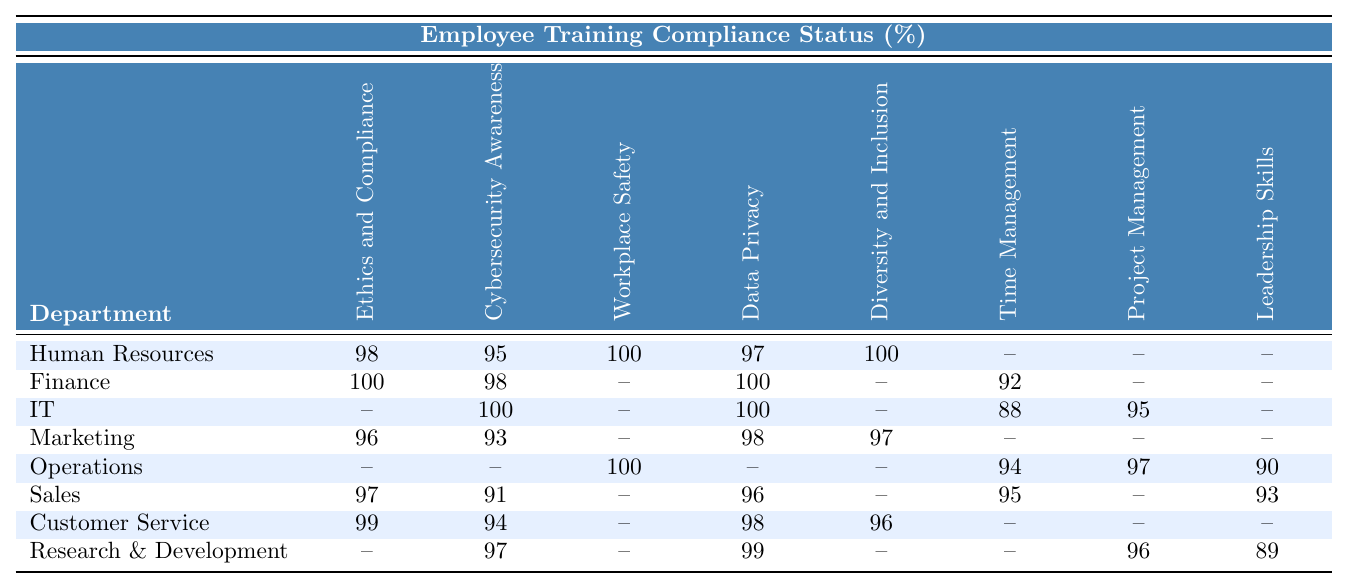What is the compliance percentage for "Diversity and Inclusion" in Human Resources? The compliance percentage for the "Diversity and Inclusion" training in the Human Resources department is explicitly listed in the table. It shows a value of 100%.
Answer: 100% Which department has the highest compliance in "Data Privacy"? The department with the highest compliance in "Data Privacy" is Finance, with a compliance rate of 100%.
Answer: Finance Are there any departments that have completed the "Workplace Safety" training? Yes, both Human Resources and Operations have completed the "Workplace Safety" training with a compliance rate of 100%.
Answer: Yes What is the average compliance percentage for "Cybersecurity Awareness" across all departments? To find the average for "Cybersecurity Awareness," we sum the values: 95 (HR) + 98 (Finance) + 100 (IT) + 93 (Marketing) + 91 (Sales) + 94 (Customer Service) + 97 (R&D) = 568. There are 7 departments that have a compliance rate recorded for this training, so we divide 568 by 7 to get approximately 81.14.
Answer: Approximately 81.14% Which department has the lowest compliance in "Time Management"? The department with the lowest compliance in "Time Management" is IT, with a compliance percentage of 88%.
Answer: IT True or false: "Sales" has a compliance rate lower than 90% for "Leadership Skills." The compliance rate for "Leadership Skills" in Sales is 93%, which is not lower than 90%, making the statement false.
Answer: False What is the compliance difference in "Project Management Fundamentals" between Operations and IT? The compliance for "Project Management Fundamentals" in Operations is 97% while in IT it is 95%. The difference is calculated as 97% - 95% = 2%.
Answer: 2% In which department is the "Ethics and Compliance" training compliance the lowest? Marketing has the lowest compliance for "Ethics and Compliance," which is recorded at 96%.
Answer: Marketing List all departments that have completed "Time Management" training with a compliance rate above 90%. Looking at the data, the departments that have "Time Management" compliance above 90% are Finance (92%), Operations (94%), Sales (95%), and HR (not applicable).
Answer: Finance, Operations, Sales What conclusions can we draw about the training compliance rates for Customer Service? Customer Service has high compliance rates for four different training modules, all above 90%: 99% for Ethics and Compliance, 94% for Cybersecurity Awareness, 98% for Data Privacy, and 96% for Diversity and Inclusion, indicating strong adherence to training.
Answer: Strong adherence to training 